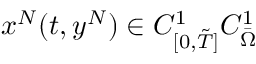<formula> <loc_0><loc_0><loc_500><loc_500>x ^ { N } ( t , y ^ { N } ) \in C _ { [ 0 , \tilde { T } ] } ^ { 1 } C _ { \ B a r { \Omega } } ^ { 1 }</formula> 